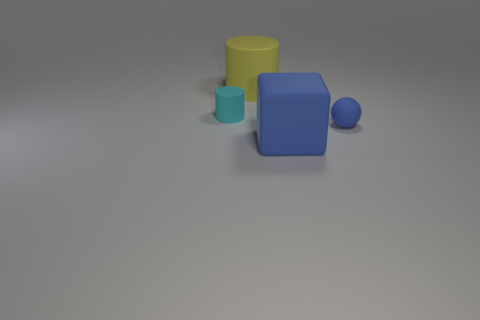Add 4 yellow matte cylinders. How many objects exist? 8 Subtract all blocks. How many objects are left? 3 Add 4 rubber things. How many rubber things are left? 8 Add 4 tiny blue objects. How many tiny blue objects exist? 5 Subtract 0 brown cubes. How many objects are left? 4 Subtract all big yellow cubes. Subtract all blocks. How many objects are left? 3 